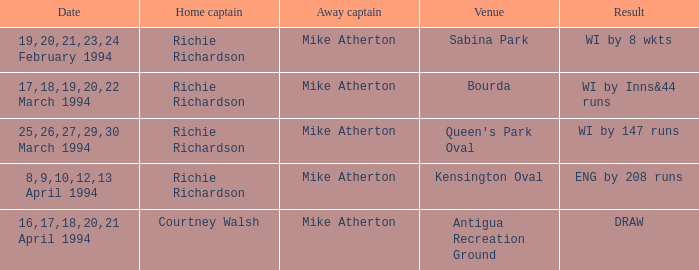What is the Venue which has a Wi by 8 wkts? Sabina Park. 